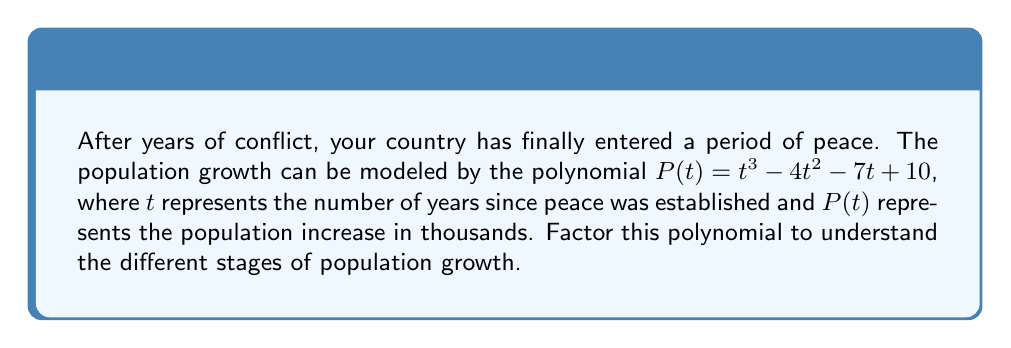Can you answer this question? Let's factor the polynomial $P(t) = t^3 - 4t^2 - 7t + 10$ step by step:

1) First, let's check if there's a common factor. There isn't, so we proceed to the next step.

2) This is a cubic polynomial. Let's try to find a factor by guessing a root. The possible rational roots are the factors of the constant term, 10: ±1, ±2, ±5, ±10.

3) Testing these values, we find that $P(1) = 1 - 4 - 7 + 10 = 0$. So, $(t-1)$ is a factor.

4) We can use polynomial long division to find the other factor:

   $$\frac{t^3 - 4t^2 - 7t + 10}{t - 1} = t^2 - 3t - 10$$

5) So, $P(t) = (t-1)(t^2 - 3t - 10)$

6) Now we need to factor the quadratic $t^2 - 3t - 10$. We can use the quadratic formula or factoring by grouping.

7) The roots of $t^2 - 3t - 10 = 0$ are $t = 5$ and $t = -2$

8) Therefore, $t^2 - 3t - 10 = (t-5)(t+2)$

9) Combining all factors, we get:

   $P(t) = (t-1)(t-5)(t+2)$

This factorization shows that the population increase will be zero when $t=1$, $t=5$, and $t=-2$ (which is not relevant as time can't be negative in this context).
Answer: $P(t) = (t-1)(t-5)(t+2)$ 